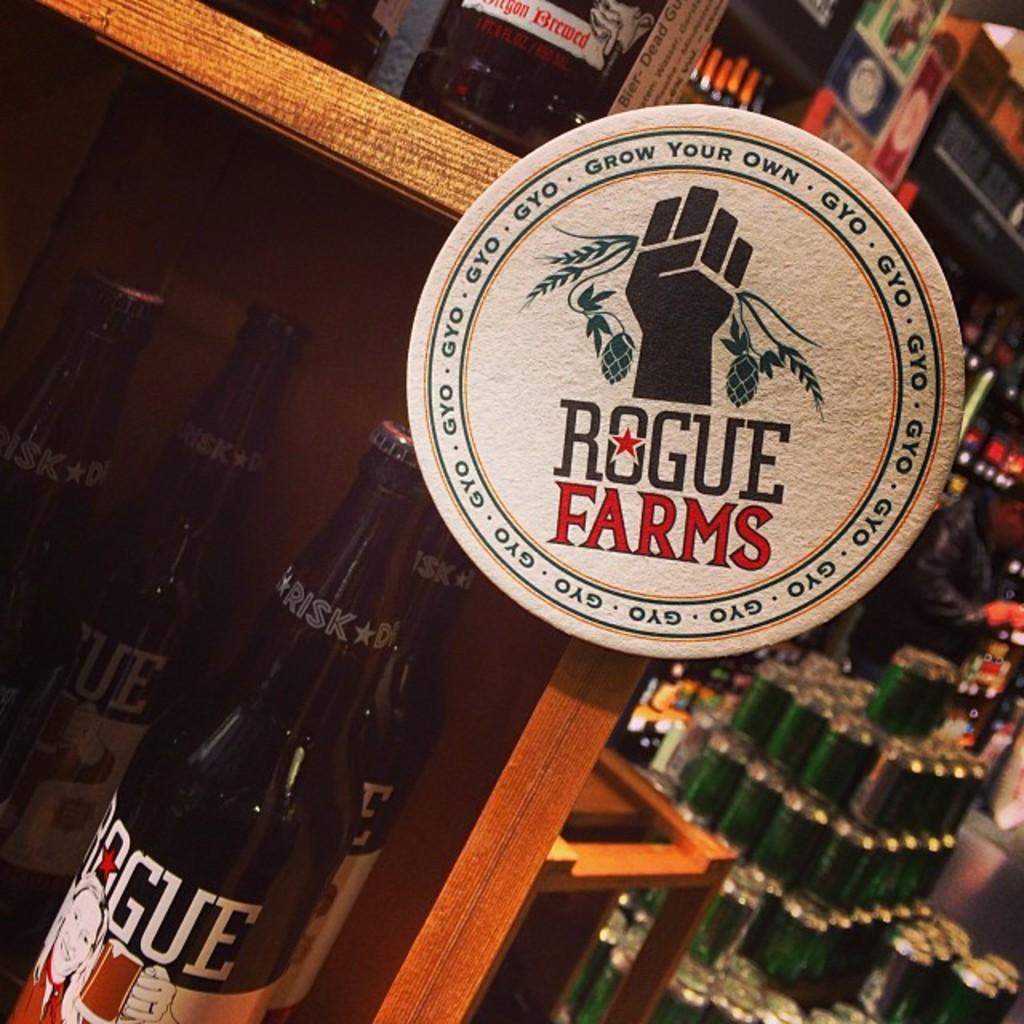Does rogue farms have an insignia?
Provide a succinct answer. Yes. Is rogue farms a beer company?
Make the answer very short. Yes. 